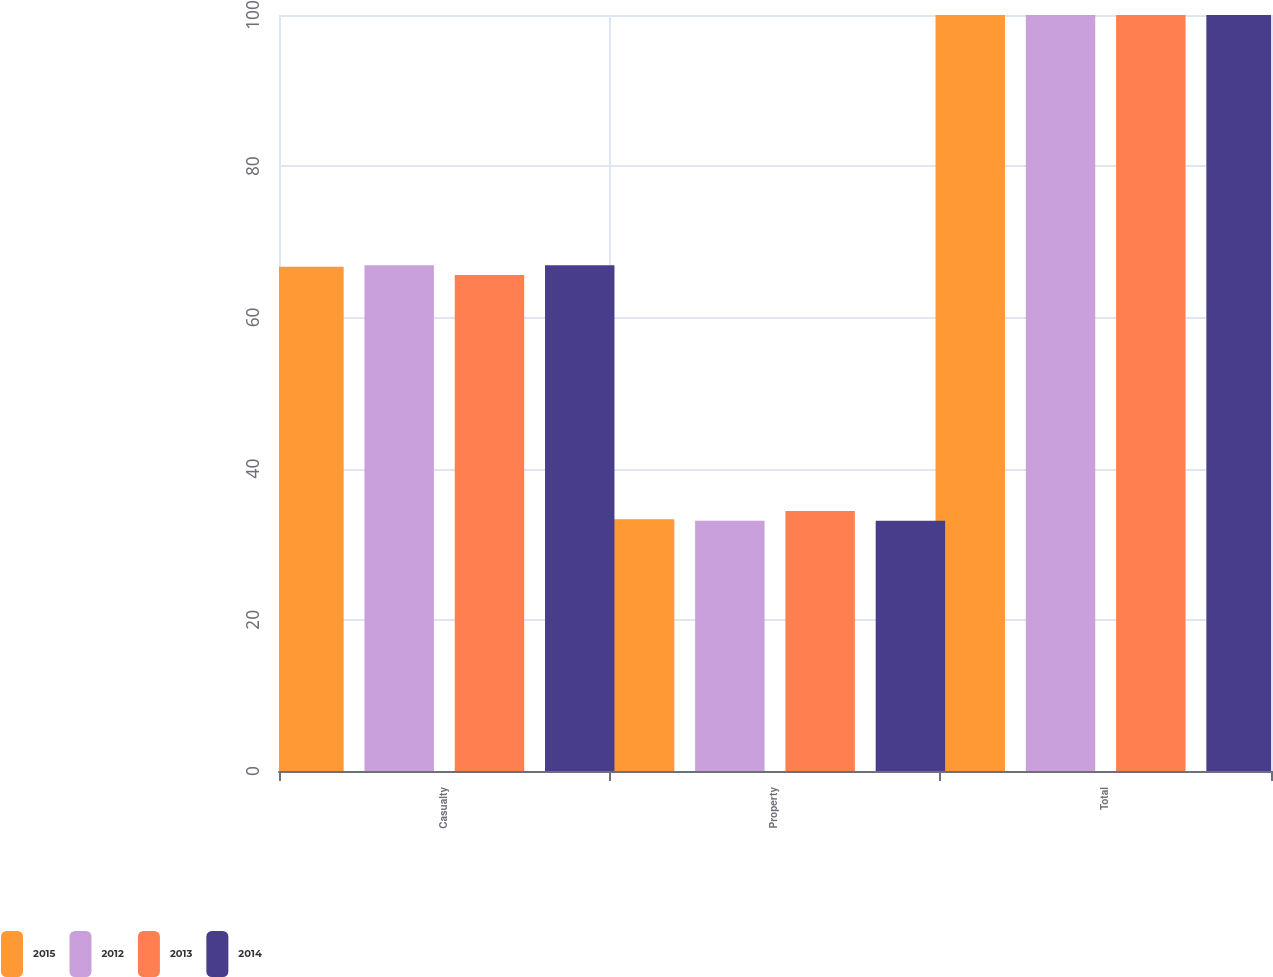Convert chart. <chart><loc_0><loc_0><loc_500><loc_500><stacked_bar_chart><ecel><fcel>Casualty<fcel>Property<fcel>Total<nl><fcel>2015<fcel>66.7<fcel>33.3<fcel>100<nl><fcel>2012<fcel>66.9<fcel>33.1<fcel>100<nl><fcel>2013<fcel>65.6<fcel>34.4<fcel>100<nl><fcel>2014<fcel>66.9<fcel>33.1<fcel>100<nl></chart> 